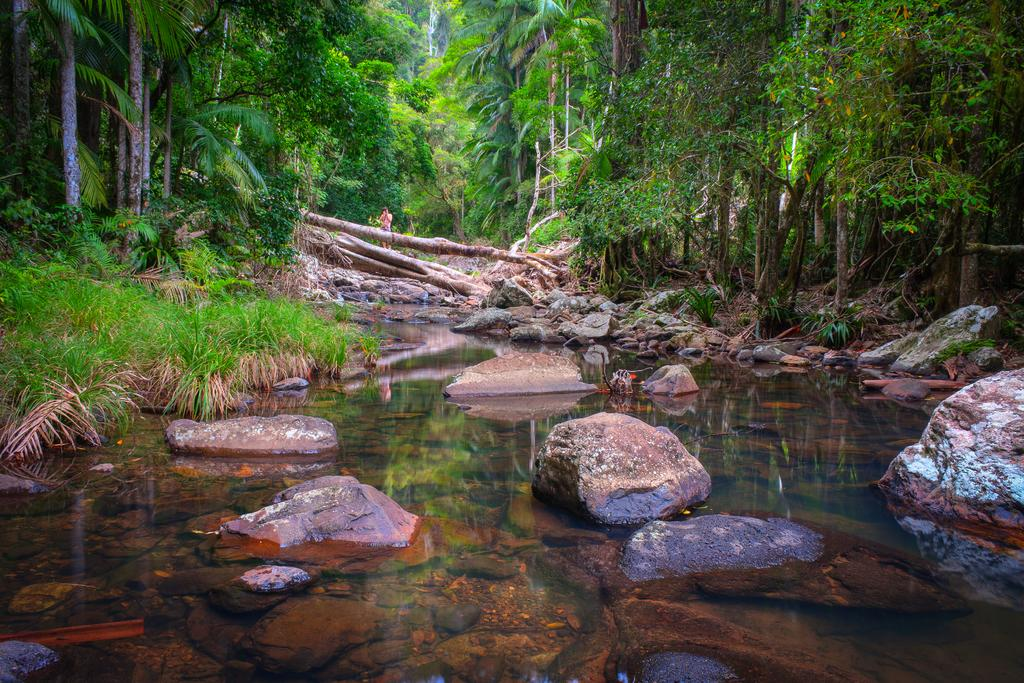What is the main subject of the image? There is a person standing in the image. What type of natural environment is depicted in the image? The image features a water body, stones, rocks, the bark of trees, grass, plants, and a group of trees. Can you describe the terrain in the image? The terrain includes stones, rocks, grass, and plants. What type of lawyer is playing basketball in the image? There is no lawyer or basketball present in the image. What type of fan is visible in the image? There is no fan present in the image. 